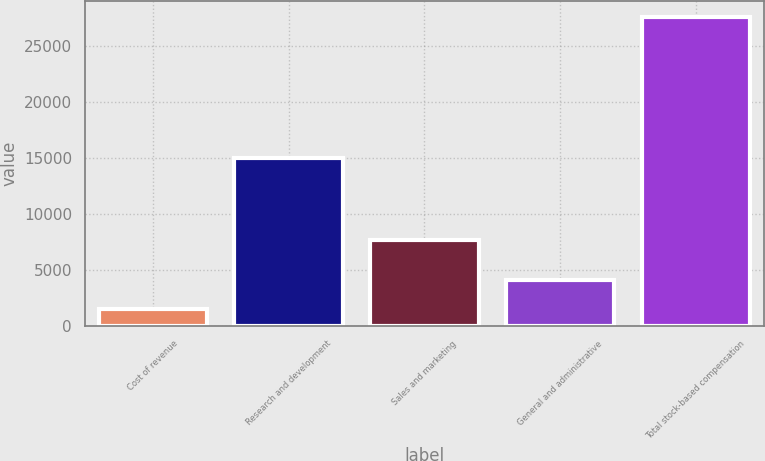<chart> <loc_0><loc_0><loc_500><loc_500><bar_chart><fcel>Cost of revenue<fcel>Research and development<fcel>Sales and marketing<fcel>General and administrative<fcel>Total stock-based compensation<nl><fcel>1535<fcel>14986<fcel>7643<fcel>4143.4<fcel>27619<nl></chart> 